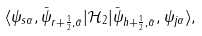<formula> <loc_0><loc_0><loc_500><loc_500>\langle \psi _ { s \alpha } , \bar { \psi } _ { r + \frac { 1 } { 2 } , \bar { \alpha } } | \mathcal { H } _ { 2 } | \bar { \psi } _ { h + \frac { 1 } { 2 } , \bar { \alpha } } , \psi _ { j \alpha } \rangle ,</formula> 